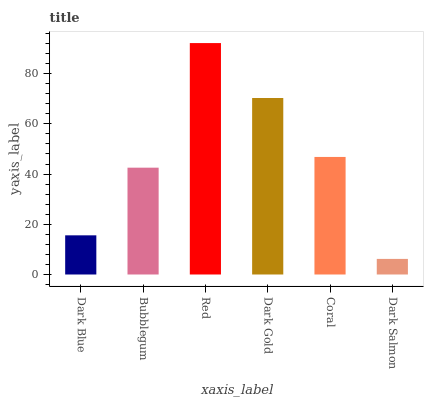Is Dark Salmon the minimum?
Answer yes or no. Yes. Is Red the maximum?
Answer yes or no. Yes. Is Bubblegum the minimum?
Answer yes or no. No. Is Bubblegum the maximum?
Answer yes or no. No. Is Bubblegum greater than Dark Blue?
Answer yes or no. Yes. Is Dark Blue less than Bubblegum?
Answer yes or no. Yes. Is Dark Blue greater than Bubblegum?
Answer yes or no. No. Is Bubblegum less than Dark Blue?
Answer yes or no. No. Is Coral the high median?
Answer yes or no. Yes. Is Bubblegum the low median?
Answer yes or no. Yes. Is Dark Salmon the high median?
Answer yes or no. No. Is Dark Gold the low median?
Answer yes or no. No. 